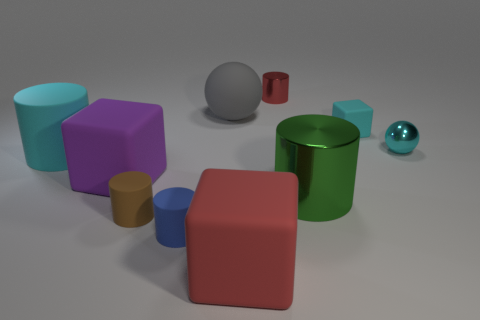What material is the big cylinder that is the same color as the tiny sphere?
Offer a very short reply. Rubber. Are there any tiny matte objects of the same shape as the big purple matte thing?
Provide a short and direct response. Yes. What number of gray things are behind the tiny rubber block?
Your response must be concise. 1. What is the sphere that is on the right side of the metal cylinder that is in front of the red metallic object made of?
Your response must be concise. Metal. There is a green object that is the same size as the red matte block; what material is it?
Provide a short and direct response. Metal. Is there a green shiny object that has the same size as the gray thing?
Keep it short and to the point. Yes. The big object that is on the right side of the red shiny thing is what color?
Offer a very short reply. Green. There is a small cylinder that is behind the cyan rubber block; is there a blue rubber object that is on the left side of it?
Provide a succinct answer. Yes. What number of other objects are there of the same color as the big rubber cylinder?
Your answer should be compact. 2. There is a sphere that is behind the cyan shiny thing; does it have the same size as the cyan matte thing that is right of the tiny blue rubber cylinder?
Your answer should be very brief. No. 